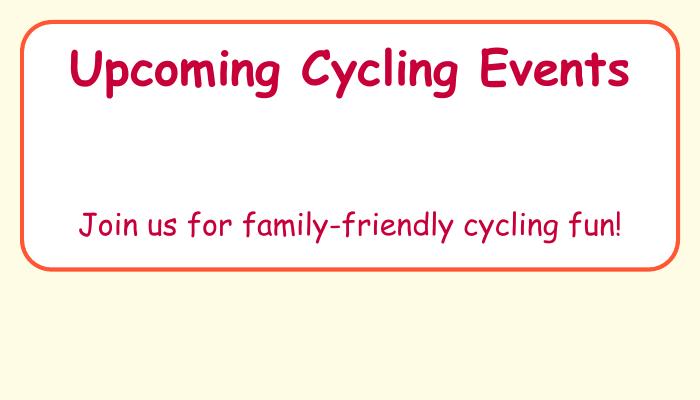what is the first event listed? The first event listed is a Family Fun Ride, which is the first item in the upcoming cycling events section.
Answer: Family Fun Ride when is the Earth Day Bike Parade? The Earth Day Bike Parade is on April 22, which is clearly stated in the event details.
Answer: April 22 where is the Family Safety Workshop held? The location of the Family Safety Workshop is Eastside Community Center, as indicated in the document.
Answer: Eastside Community Center how many events are listed in total? There are four events listed in the upcoming cycling events section, counting each individual event.
Answer: 4 what time does the Spring Community Cycle start? The Spring Community Cycle starts at 9:00 AM, which is specified next to the event title.
Answer: 9:00 AM which event takes place on April 29? The event that takes place on April 29 is the Family Safety Workshop, as listed in the document.
Answer: Family Safety Workshop what is the color of the document’s background? The document’s background color is a light yellow, which can be identified by looking at the document style.
Answer: yellow what type of events are featured in this document? The events featured in this document focus on cycling activities, particularly family-oriented ones.
Answer: cycling events 